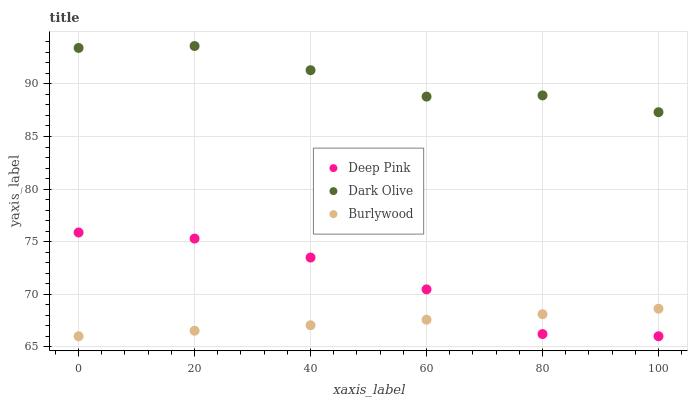Does Burlywood have the minimum area under the curve?
Answer yes or no. Yes. Does Dark Olive have the maximum area under the curve?
Answer yes or no. Yes. Does Deep Pink have the minimum area under the curve?
Answer yes or no. No. Does Deep Pink have the maximum area under the curve?
Answer yes or no. No. Is Burlywood the smoothest?
Answer yes or no. Yes. Is Deep Pink the roughest?
Answer yes or no. Yes. Is Deep Pink the smoothest?
Answer yes or no. No. Is Burlywood the roughest?
Answer yes or no. No. Does Burlywood have the lowest value?
Answer yes or no. Yes. Does Dark Olive have the highest value?
Answer yes or no. Yes. Does Deep Pink have the highest value?
Answer yes or no. No. Is Burlywood less than Dark Olive?
Answer yes or no. Yes. Is Dark Olive greater than Burlywood?
Answer yes or no. Yes. Does Burlywood intersect Deep Pink?
Answer yes or no. Yes. Is Burlywood less than Deep Pink?
Answer yes or no. No. Is Burlywood greater than Deep Pink?
Answer yes or no. No. Does Burlywood intersect Dark Olive?
Answer yes or no. No. 